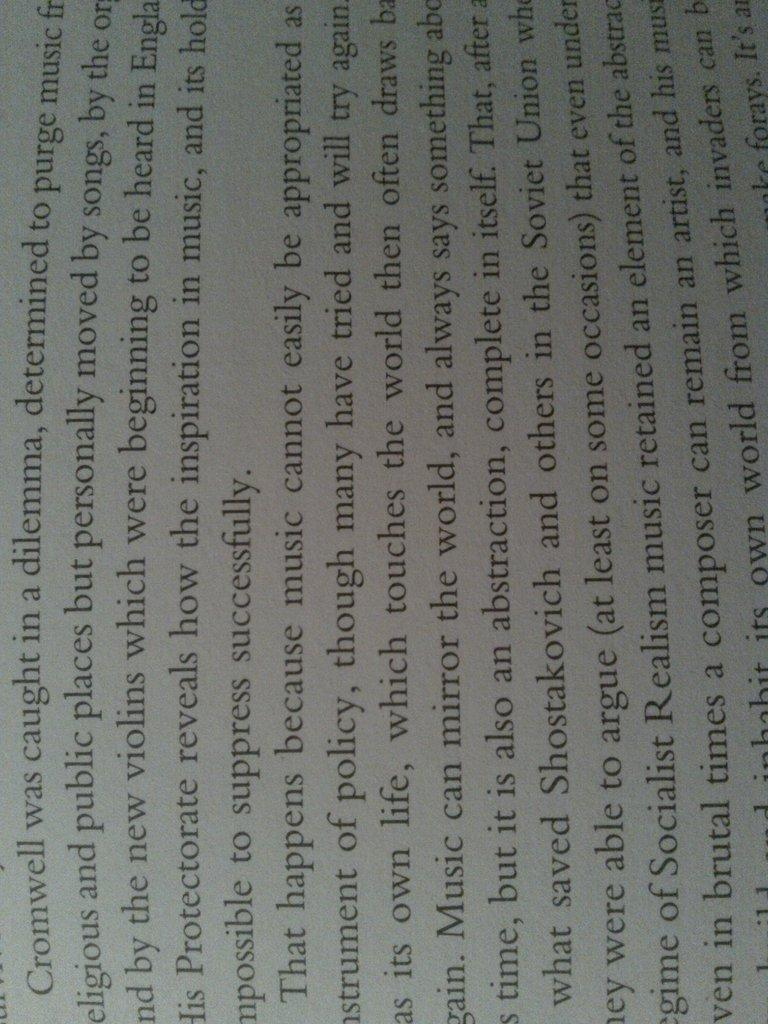<image>
Write a terse but informative summary of the picture. A book page features the names Shostakovich and Cromwell. 